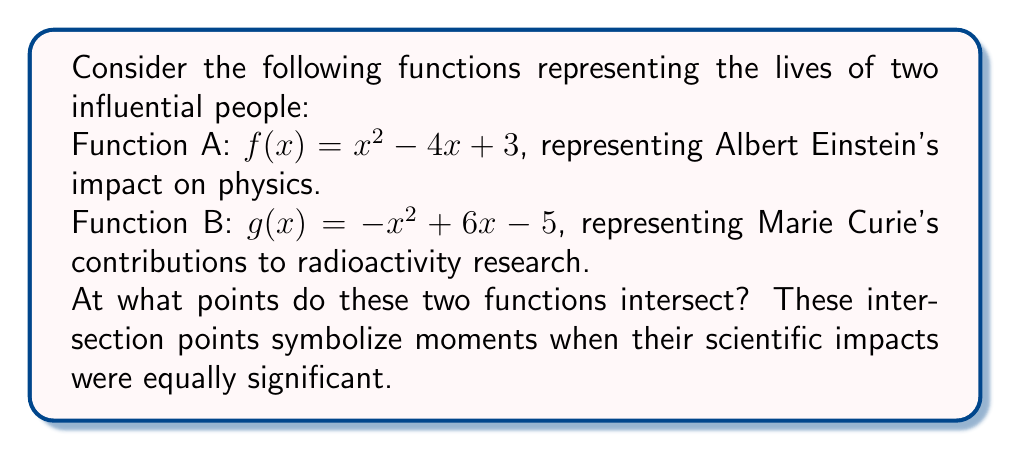Teach me how to tackle this problem. To find the intersection points, we need to solve the equation $f(x) = g(x)$:

1) Set the equations equal to each other:
   $x^2 - 4x + 3 = -x^2 + 6x - 5$

2) Rearrange all terms to one side:
   $2x^2 - 10x + 8 = 0$

3) Divide all terms by 2 to simplify:
   $x^2 - 5x + 4 = 0$

4) This is a quadratic equation. We can solve it using the quadratic formula:
   $x = \frac{-b \pm \sqrt{b^2 - 4ac}}{2a}$

   Where $a = 1$, $b = -5$, and $c = 4$

5) Substituting these values:
   $x = \frac{5 \pm \sqrt{25 - 16}}{2} = \frac{5 \pm \sqrt{9}}{2} = \frac{5 \pm 3}{2}$

6) This gives us two solutions:
   $x_1 = \frac{5 + 3}{2} = 4$ and $x_2 = \frac{5 - 3}{2} = 1$

7) To find the y-coordinates, substitute these x-values into either function:
   For $x = 4$: $f(4) = 4^2 - 4(4) + 3 = 16 - 16 + 3 = 3$
   For $x = 1$: $f(1) = 1^2 - 4(1) + 3 = 1 - 4 + 3 = 0$

Therefore, the intersection points are (4, 3) and (1, 0).
Answer: (4, 3) and (1, 0) 